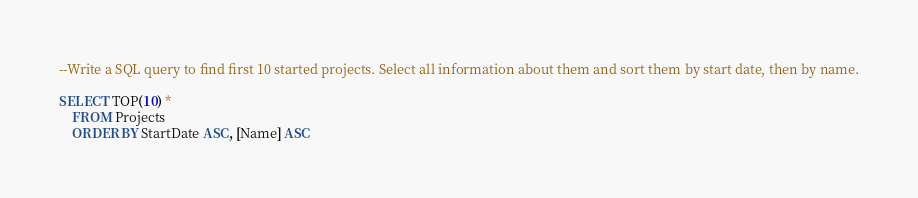Convert code to text. <code><loc_0><loc_0><loc_500><loc_500><_SQL_>--Write a SQL query to find first 10 started projects. Select all information about them and sort them by start date, then by name.

SELECT TOP(10) *
	FROM Projects
	ORDER BY StartDate ASC, [Name] ASC</code> 